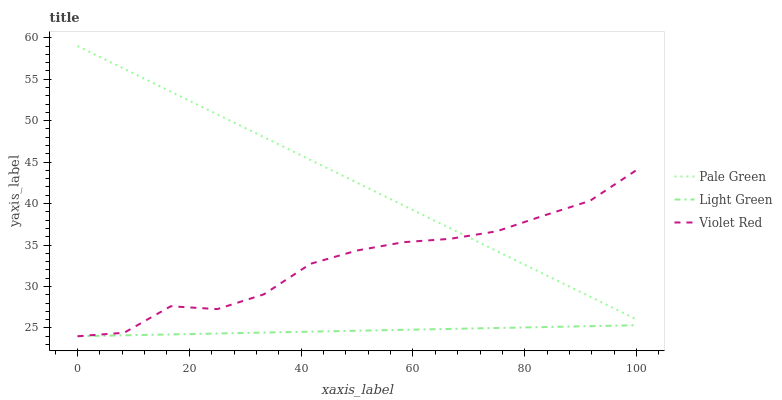Does Light Green have the minimum area under the curve?
Answer yes or no. Yes. Does Pale Green have the maximum area under the curve?
Answer yes or no. Yes. Does Pale Green have the minimum area under the curve?
Answer yes or no. No. Does Light Green have the maximum area under the curve?
Answer yes or no. No. Is Light Green the smoothest?
Answer yes or no. Yes. Is Violet Red the roughest?
Answer yes or no. Yes. Is Pale Green the smoothest?
Answer yes or no. No. Is Pale Green the roughest?
Answer yes or no. No. Does Violet Red have the lowest value?
Answer yes or no. Yes. Does Pale Green have the lowest value?
Answer yes or no. No. Does Pale Green have the highest value?
Answer yes or no. Yes. Does Light Green have the highest value?
Answer yes or no. No. Is Light Green less than Pale Green?
Answer yes or no. Yes. Is Pale Green greater than Light Green?
Answer yes or no. Yes. Does Violet Red intersect Light Green?
Answer yes or no. Yes. Is Violet Red less than Light Green?
Answer yes or no. No. Is Violet Red greater than Light Green?
Answer yes or no. No. Does Light Green intersect Pale Green?
Answer yes or no. No. 